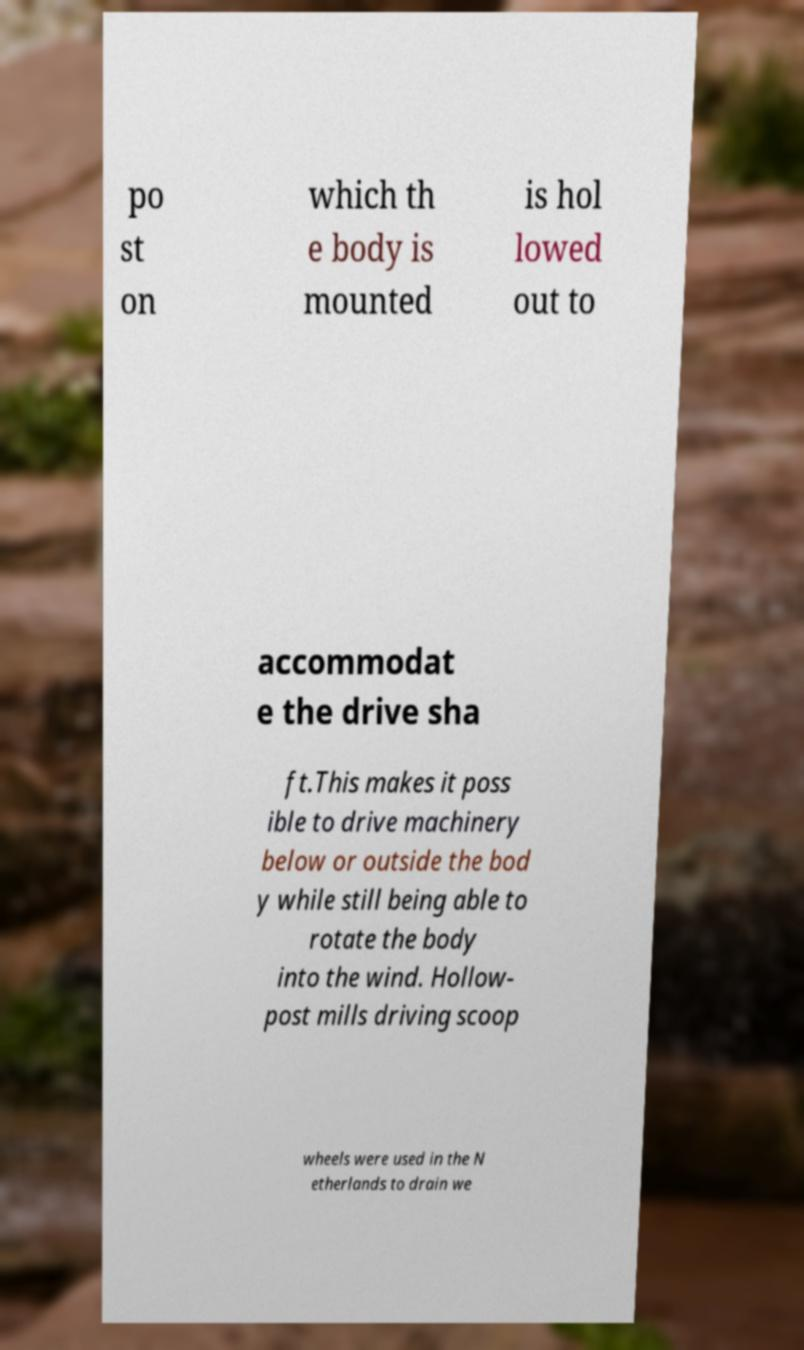Please identify and transcribe the text found in this image. po st on which th e body is mounted is hol lowed out to accommodat e the drive sha ft.This makes it poss ible to drive machinery below or outside the bod y while still being able to rotate the body into the wind. Hollow- post mills driving scoop wheels were used in the N etherlands to drain we 